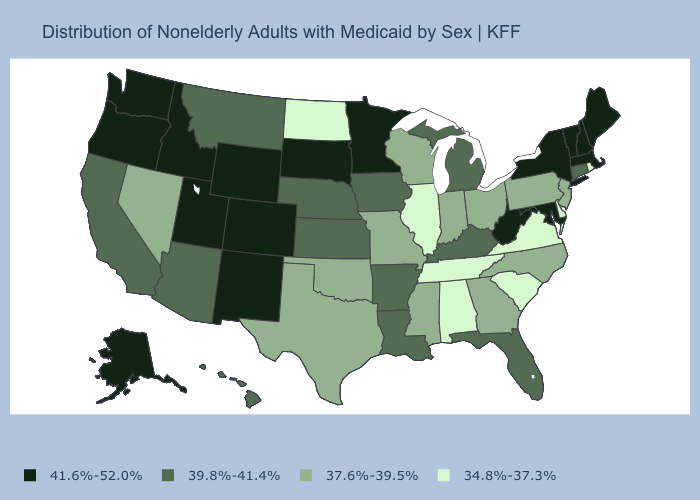Name the states that have a value in the range 41.6%-52.0%?
Give a very brief answer. Alaska, Colorado, Idaho, Maine, Maryland, Massachusetts, Minnesota, New Hampshire, New Mexico, New York, Oregon, South Dakota, Utah, Vermont, Washington, West Virginia, Wyoming. Which states have the highest value in the USA?
Short answer required. Alaska, Colorado, Idaho, Maine, Maryland, Massachusetts, Minnesota, New Hampshire, New Mexico, New York, Oregon, South Dakota, Utah, Vermont, Washington, West Virginia, Wyoming. Name the states that have a value in the range 39.8%-41.4%?
Keep it brief. Arizona, Arkansas, California, Connecticut, Florida, Hawaii, Iowa, Kansas, Kentucky, Louisiana, Michigan, Montana, Nebraska. What is the value of Arizona?
Answer briefly. 39.8%-41.4%. Name the states that have a value in the range 41.6%-52.0%?
Write a very short answer. Alaska, Colorado, Idaho, Maine, Maryland, Massachusetts, Minnesota, New Hampshire, New Mexico, New York, Oregon, South Dakota, Utah, Vermont, Washington, West Virginia, Wyoming. Does Vermont have a higher value than Nebraska?
Keep it brief. Yes. What is the value of New Mexico?
Short answer required. 41.6%-52.0%. What is the value of California?
Write a very short answer. 39.8%-41.4%. What is the value of Oklahoma?
Answer briefly. 37.6%-39.5%. What is the value of Texas?
Quick response, please. 37.6%-39.5%. Name the states that have a value in the range 39.8%-41.4%?
Short answer required. Arizona, Arkansas, California, Connecticut, Florida, Hawaii, Iowa, Kansas, Kentucky, Louisiana, Michigan, Montana, Nebraska. Which states hav the highest value in the Northeast?
Short answer required. Maine, Massachusetts, New Hampshire, New York, Vermont. Does Alaska have the highest value in the USA?
Short answer required. Yes. 